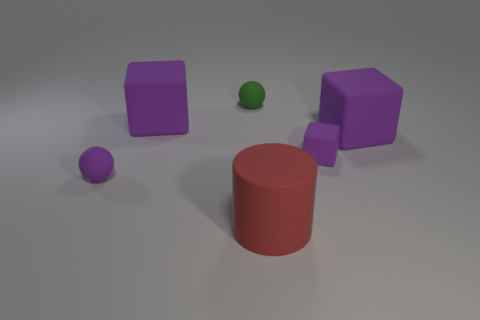Are there any other things that have the same shape as the red thing?
Your answer should be compact. No. Are the tiny purple ball and the small thing that is to the right of the red matte thing made of the same material?
Your answer should be compact. Yes. The small sphere right of the matte ball that is to the left of the green object behind the red matte cylinder is what color?
Give a very brief answer. Green. Is there any other thing that is the same size as the green sphere?
Ensure brevity in your answer.  Yes. There is a rubber cylinder; is its color the same as the sphere that is to the right of the purple sphere?
Give a very brief answer. No. The cylinder is what color?
Keep it short and to the point. Red. The big matte object in front of the tiny purple thing left of the big purple thing that is on the left side of the red matte cylinder is what shape?
Keep it short and to the point. Cylinder. What number of other objects are there of the same color as the big matte cylinder?
Keep it short and to the point. 0. Is the number of purple rubber spheres that are to the right of the green matte object greater than the number of matte cylinders left of the tiny purple ball?
Offer a very short reply. No. Are there any small green balls right of the matte cylinder?
Your response must be concise. No. 